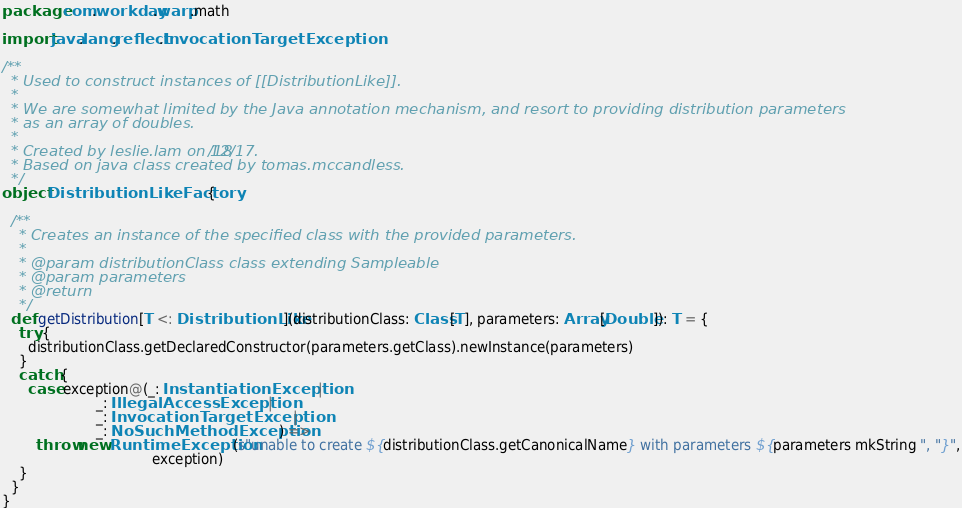Convert code to text. <code><loc_0><loc_0><loc_500><loc_500><_Scala_>package com.workday.warp.math

import java.lang.reflect.InvocationTargetException

/**
  * Used to construct instances of [[DistributionLike]].
  *
  * We are somewhat limited by the Java annotation mechanism, and resort to providing distribution parameters
  * as an array of doubles.
  *
  * Created by leslie.lam on 12/18/17.
  * Based on java class created by tomas.mccandless.
  */
object DistributionLikeFactory {

  /**
    * Creates an instance of the specified class with the provided parameters.
    *
    * @param distributionClass class extending Sampleable
    * @param parameters
    * @return
    */
  def getDistribution[T <: DistributionLike](distributionClass: Class[T], parameters: Array[Double]): T = {
    try {
      distributionClass.getDeclaredConstructor(parameters.getClass).newInstance(parameters)
    }
    catch {
      case exception@(_: InstantiationException |
                      _: IllegalAccessException |
                      _: InvocationTargetException |
                      _: NoSuchMethodException) =>
        throw new RuntimeException(s"unable to create ${distributionClass.getCanonicalName} with parameters ${parameters mkString ", "}",
                                   exception)
    }
  }
}
</code> 